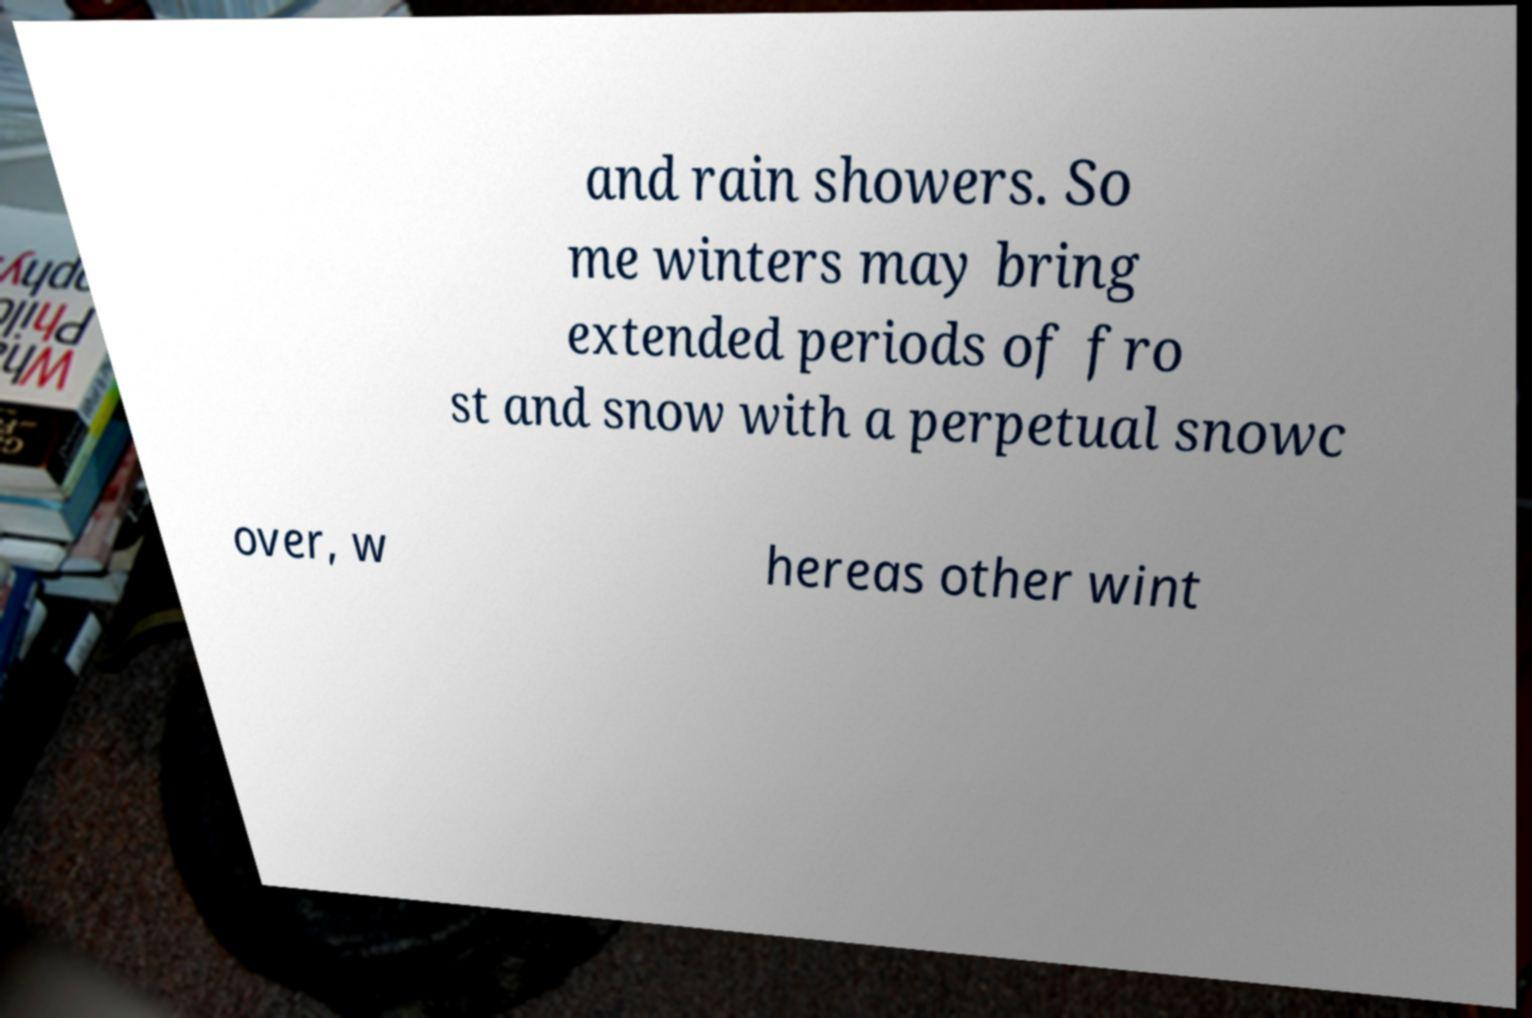For documentation purposes, I need the text within this image transcribed. Could you provide that? and rain showers. So me winters may bring extended periods of fro st and snow with a perpetual snowc over, w hereas other wint 